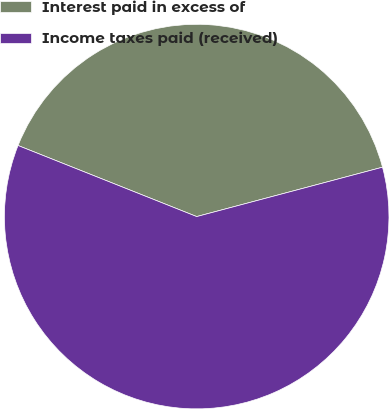<chart> <loc_0><loc_0><loc_500><loc_500><pie_chart><fcel>Interest paid in excess of<fcel>Income taxes paid (received)<nl><fcel>39.84%<fcel>60.16%<nl></chart> 